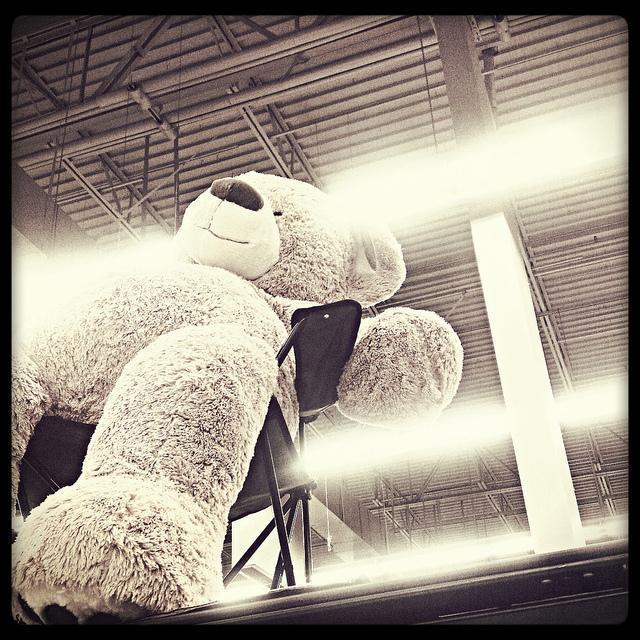How many suitcases are in this photo?
Give a very brief answer. 0. 